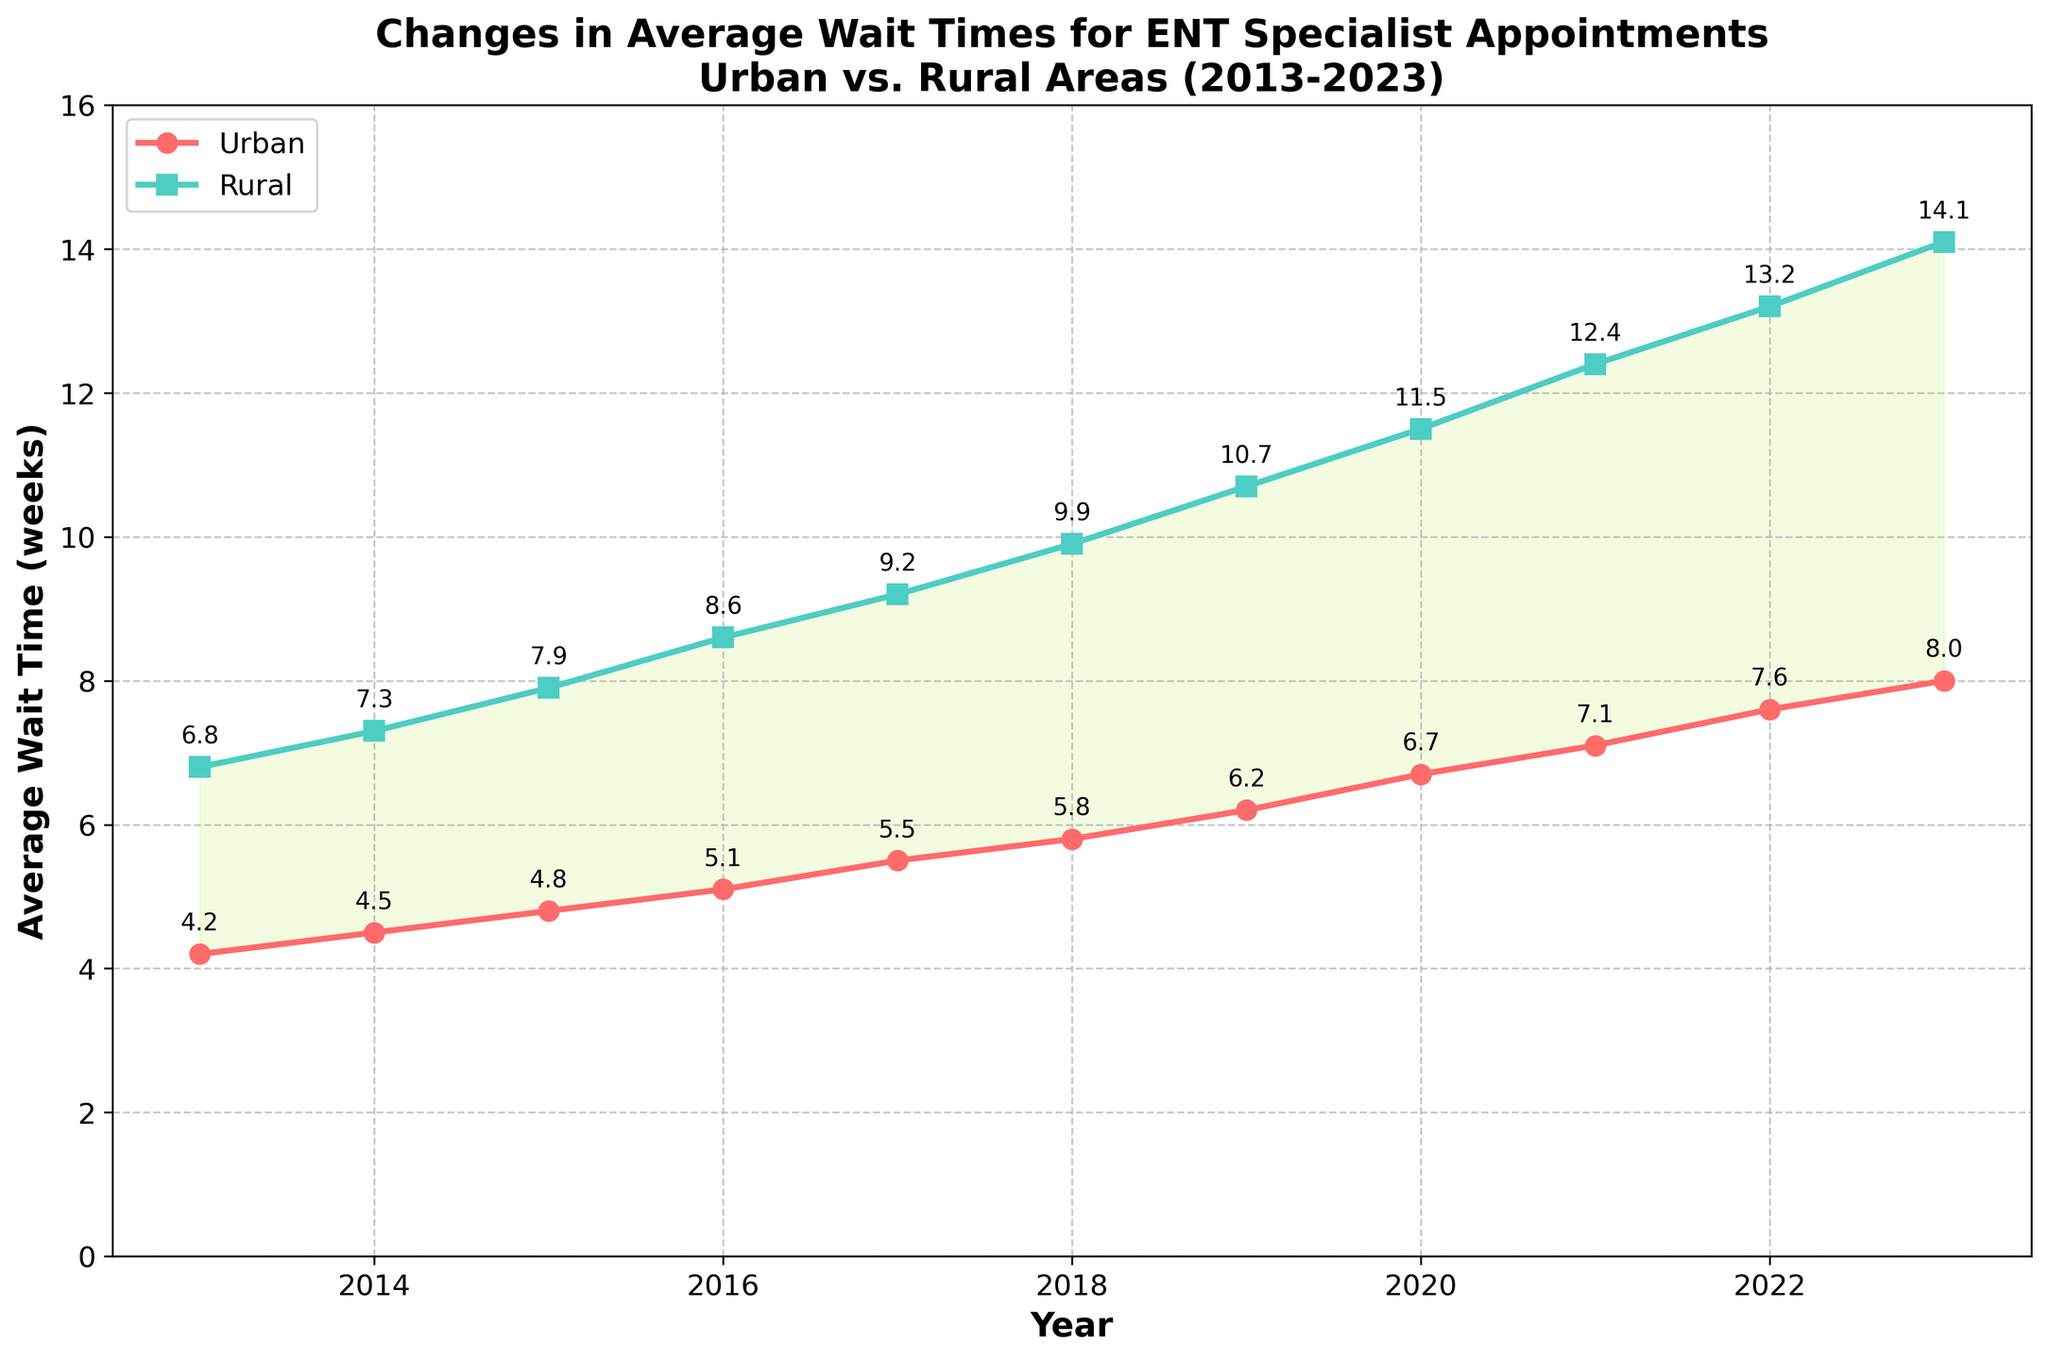What's the trend in average wait times for urban areas from 2013 to 2023? To determine the trend, look at how the urban wait times change over the years. From 2013 to 2023, the urban wait times increase each year, indicating an upward trend.
Answer: Upward trend Compare the wait times for rural and urban areas in 2019. Which area had a longer wait time and by how much? In 2019, the urban wait time is 6.2 weeks, and the rural wait time is 10.7 weeks. Subtracting the urban wait time from the rural wait time gives the difference: 10.7 - 6.2 = 4.5 weeks.
Answer: Rural by 4.5 weeks What is the percentage increase in rural wait times from 2013 to 2023? First, calculate the difference between the rural wait times in 2023 and 2013: 14.1 - 6.8 = 7.3 weeks. Then, divide this difference by the rural wait time in 2013 and multiply by 100 to get the percentage: (7.3 / 6.8) * 100 ≈ 107.35%.
Answer: 107.35% What year shows the largest difference between rural and urban wait times? Compare the differences by subtracting the urban wait time from the rural wait time for each year. 2023 has the largest difference: 14.1 - 8.0 = 6.1 weeks.
Answer: 2023 On average, how much do urban wait times increase each year from 2013 to 2023? Calculate the total increase in urban wait times from 2013 to 2023: 8.0 - 4.2 = 3.8 weeks. Then, divide this increase by the number of years (10): 3.8 / 10 = 0.38 weeks per year.
Answer: 0.38 weeks per year In which year was the fastest growth in rural wait times observed? Examine the yearly differences in rural wait times. The biggest increase occurred from 2016 to 2017, where the wait time jumped from 8.6 to 9.2 weeks (0.6 weeks).
Answer: 2016 to 2017 What is the average wait time difference between rural and urban areas over the whole period 2013-2023? First, find the difference between rural and urban wait times for each year, sum these differences, then divide by the number of years. Differences: 2.6, 2.8, 3.1, 3.5, 3.7, 4.1, 4.5, 4.8, 5.3, 5.6, 6.1. Sum = 45.1. Average = 45.1 / 11 ≈ 4.1 weeks.
Answer: 4.1 weeks Are there any years where the wait time in urban areas decreased? Assess the line plot for urban wait times to see if there is any downward movement. The urban wait times consistently increase every year.
Answer: No What visual element shows the difference in wait times between urban and rural areas? The shaded area between the two lines (urban and rural) visually represents the difference in wait times.
Answer: Shaded area How do the annotations help in understanding the specific wait times for each year for both urban and rural areas? The annotations display the exact wait time values at each data point, making it easier to identify specific wait times without estimating from the line plot.
Answer: Displays exact wait times 